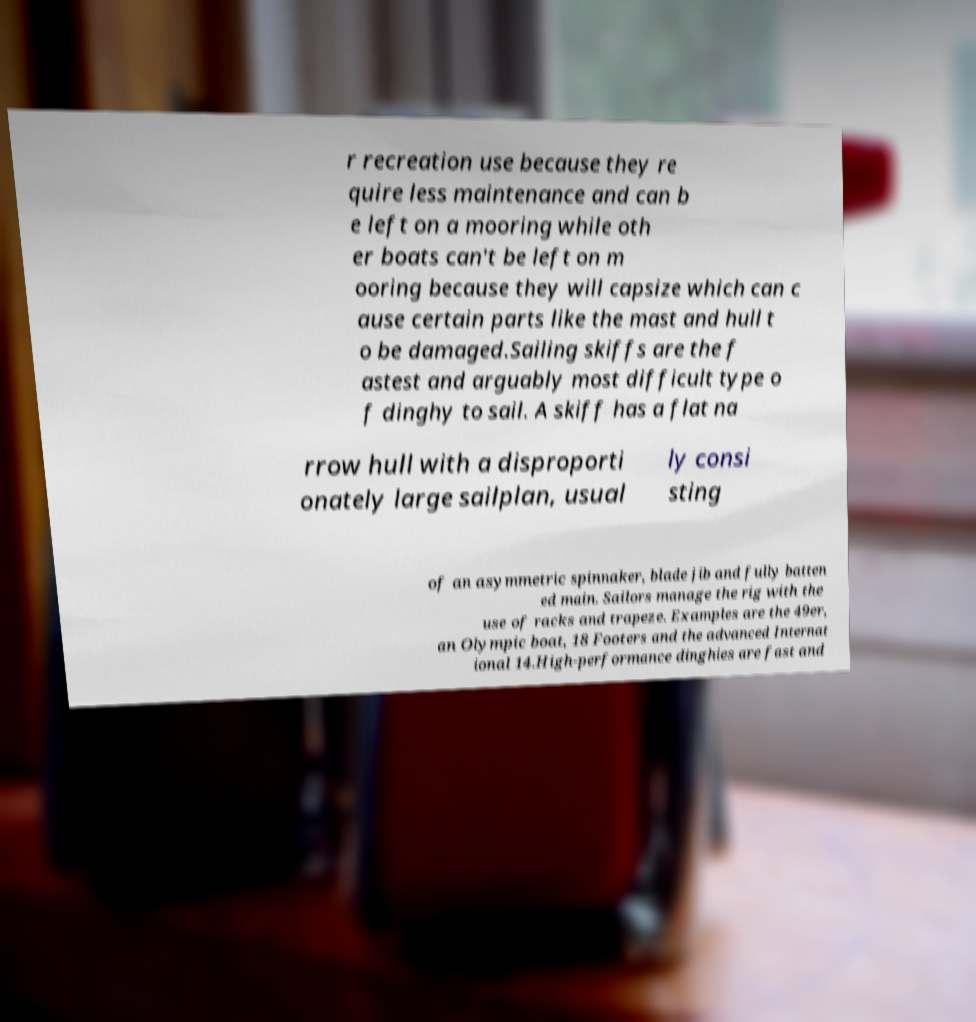What messages or text are displayed in this image? I need them in a readable, typed format. r recreation use because they re quire less maintenance and can b e left on a mooring while oth er boats can't be left on m ooring because they will capsize which can c ause certain parts like the mast and hull t o be damaged.Sailing skiffs are the f astest and arguably most difficult type o f dinghy to sail. A skiff has a flat na rrow hull with a disproporti onately large sailplan, usual ly consi sting of an asymmetric spinnaker, blade jib and fully batten ed main. Sailors manage the rig with the use of racks and trapeze. Examples are the 49er, an Olympic boat, 18 Footers and the advanced Internat ional 14.High-performance dinghies are fast and 